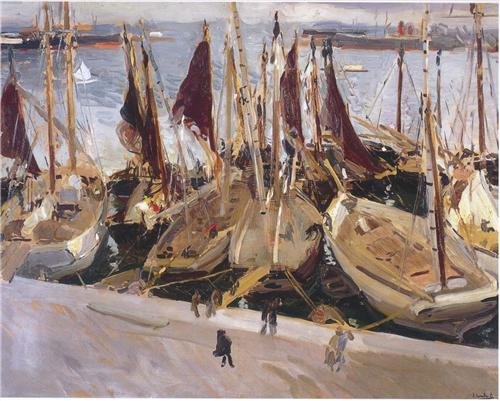Imagine you are one of the figures in the painting. Describe your day so far and your thoughts. As I stand on the dock, I notice the crisp morning air carries the salty scent of the sea. Today is promising to be a productive day with the bustling energy of the harbor fueling my enthusiasm. The boats are neatly moored, their sails furled, awaiting the day’s adventures. Fishermen and traders converse animatedly, and the gentle clinking of boat masts adds a rhythmic soundtrack to our activities. I’m part of this vibrant tapestry, contributing to an ever-unfolding tale of human endeavor and maritime tradition. My thoughts are a blend of business and appreciation for the simple beauty around me, acknowledging the seamless blend of human activity and nature's calm that defines our thriving seaside town. 